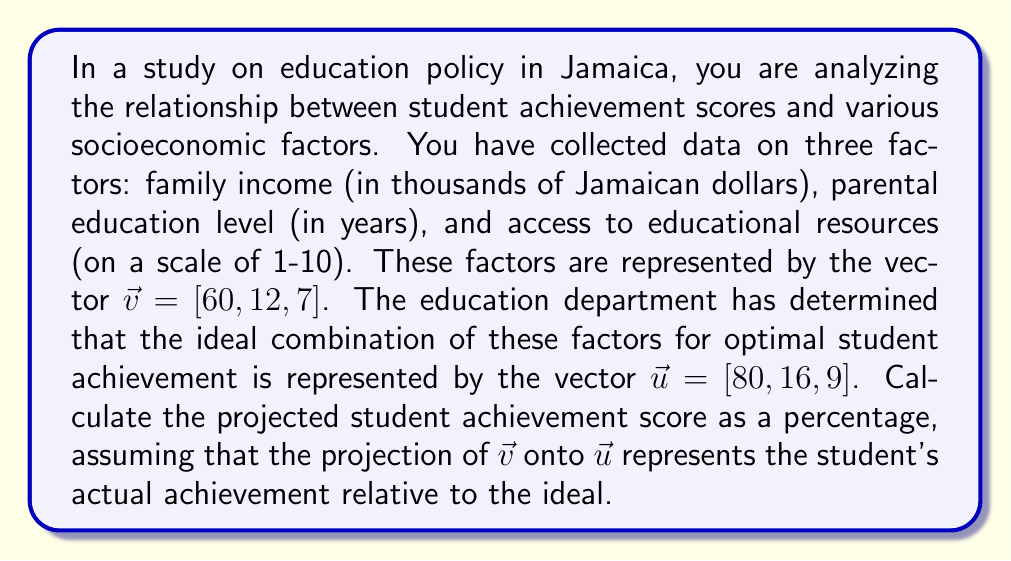Give your solution to this math problem. To solve this problem, we need to follow these steps:

1) First, we need to calculate the projection of $\vec{v}$ onto $\vec{u}$. The formula for vector projection is:

   $$\text{proj}_{\vec{u}}\vec{v} = \frac{\vec{v} \cdot \vec{u}}{\|\vec{u}\|^2} \vec{u}$$

2) Let's calculate the dot product $\vec{v} \cdot \vec{u}$:
   
   $$\vec{v} \cdot \vec{u} = 60 \cdot 80 + 12 \cdot 16 + 7 \cdot 9 = 4800 + 192 + 63 = 5055$$

3) Now, let's calculate $\|\vec{u}\|^2$:
   
   $$\|\vec{u}\|^2 = 80^2 + 16^2 + 9^2 = 6400 + 256 + 81 = 6737$$

4) Now we can calculate the scalar projection:

   $$\frac{\vec{v} \cdot \vec{u}}{\|\vec{u}\|^2} = \frac{5055}{6737} \approx 0.7503$$

5) This scalar value represents how much of $\vec{v}$ is in the direction of $\vec{u}$. To get the percentage, we multiply by 100:

   $$0.7503 \cdot 100 \approx 75.03\%$$

This percentage represents the student's projected achievement score relative to the ideal combination of factors.
Answer: The projected student achievement score is approximately 75.03%. 